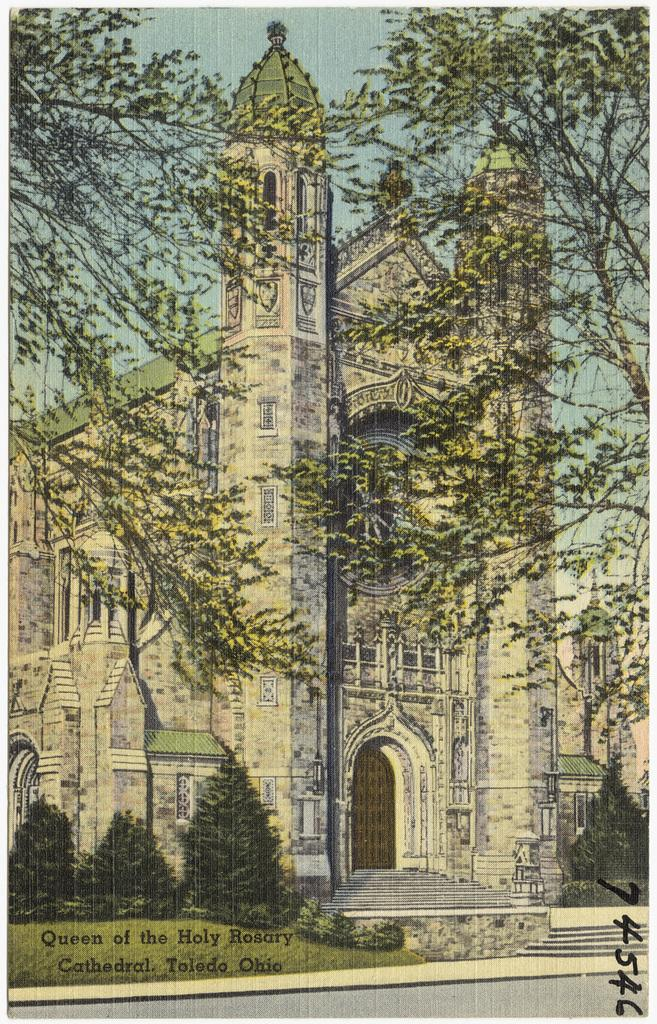What is the main subject of the poster in the image? The main subject of the poster in the image is a building. What is located at the bottom of the poster? At the bottom of the poster, there is grass, a staircase, and a road. Are there any natural elements present in the poster? Yes, trees are present at the bottom and top of the poster. What is visible at the top of the poster? At the top of the poster, the sky and trees are visible. What else can be found on the poster? Text is included on the poster. What type of verse can be seen at the top of the poster? There is no verse present at the top of the poster; it features the sky and trees. What kind of apparatus is used to climb the staircase in the poster? There is no apparatus mentioned or depicted in the poster; it simply shows a staircase. 